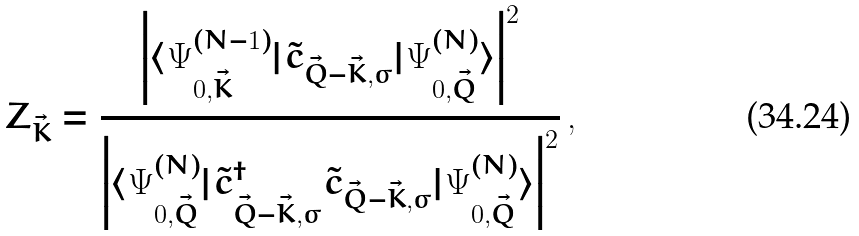Convert formula to latex. <formula><loc_0><loc_0><loc_500><loc_500>Z _ { \vec { K } } = \frac { \left | \langle { \mathit \Psi } _ { 0 , \vec { K } } ^ { ( N - 1 ) } | \tilde { c } _ { \vec { Q } - \vec { K } , \sigma } | { \mathit \Psi } _ { 0 , \vec { Q } } ^ { ( N ) } \rangle \right | ^ { 2 } } { \left | \langle { \mathit \Psi } _ { 0 , \vec { Q } } ^ { ( N ) } | \tilde { c } ^ { \dagger } _ { \vec { Q } - \vec { K } , \sigma } \tilde { c } _ { \vec { Q } - \vec { K } , \sigma } | { \mathit \Psi } _ { 0 , \vec { Q } } ^ { ( N ) } \rangle \right | ^ { 2 } } \, ,</formula> 